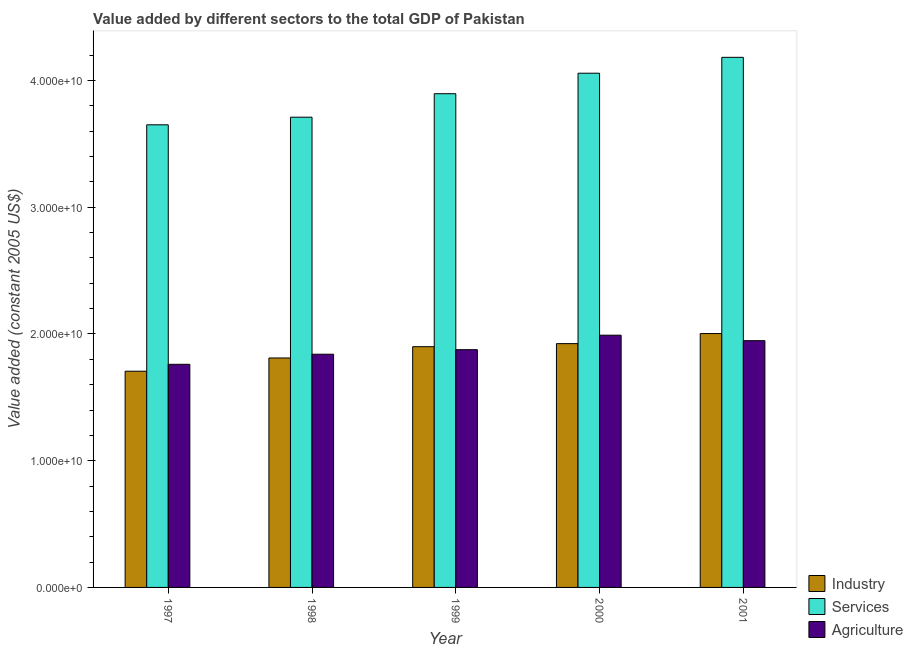How many different coloured bars are there?
Your answer should be compact. 3. How many groups of bars are there?
Your answer should be very brief. 5. Are the number of bars per tick equal to the number of legend labels?
Give a very brief answer. Yes. Are the number of bars on each tick of the X-axis equal?
Offer a terse response. Yes. What is the label of the 1st group of bars from the left?
Your answer should be compact. 1997. What is the value added by services in 2000?
Your answer should be compact. 4.06e+1. Across all years, what is the maximum value added by services?
Offer a very short reply. 4.18e+1. Across all years, what is the minimum value added by services?
Offer a very short reply. 3.65e+1. In which year was the value added by services minimum?
Offer a very short reply. 1997. What is the total value added by services in the graph?
Keep it short and to the point. 1.95e+11. What is the difference between the value added by services in 1997 and that in 2001?
Your answer should be compact. -5.32e+09. What is the difference between the value added by industrial sector in 2001 and the value added by services in 1997?
Your answer should be compact. 2.97e+09. What is the average value added by agricultural sector per year?
Your answer should be very brief. 1.88e+1. In the year 1997, what is the difference between the value added by services and value added by agricultural sector?
Offer a very short reply. 0. What is the ratio of the value added by services in 1998 to that in 2000?
Provide a succinct answer. 0.91. Is the value added by agricultural sector in 1998 less than that in 2001?
Offer a terse response. Yes. Is the difference between the value added by agricultural sector in 1997 and 2000 greater than the difference between the value added by services in 1997 and 2000?
Give a very brief answer. No. What is the difference between the highest and the second highest value added by industrial sector?
Make the answer very short. 7.95e+08. What is the difference between the highest and the lowest value added by agricultural sector?
Offer a very short reply. 2.30e+09. In how many years, is the value added by agricultural sector greater than the average value added by agricultural sector taken over all years?
Your response must be concise. 2. Is the sum of the value added by industrial sector in 1997 and 2000 greater than the maximum value added by agricultural sector across all years?
Ensure brevity in your answer.  Yes. What does the 3rd bar from the left in 1998 represents?
Give a very brief answer. Agriculture. What does the 2nd bar from the right in 1998 represents?
Keep it short and to the point. Services. Is it the case that in every year, the sum of the value added by industrial sector and value added by services is greater than the value added by agricultural sector?
Your response must be concise. Yes. Are all the bars in the graph horizontal?
Ensure brevity in your answer.  No. Does the graph contain any zero values?
Your answer should be compact. No. Does the graph contain grids?
Your answer should be compact. No. Where does the legend appear in the graph?
Make the answer very short. Bottom right. How many legend labels are there?
Give a very brief answer. 3. What is the title of the graph?
Offer a very short reply. Value added by different sectors to the total GDP of Pakistan. Does "Coal sources" appear as one of the legend labels in the graph?
Offer a very short reply. No. What is the label or title of the Y-axis?
Your answer should be compact. Value added (constant 2005 US$). What is the Value added (constant 2005 US$) of Industry in 1997?
Offer a very short reply. 1.71e+1. What is the Value added (constant 2005 US$) of Services in 1997?
Ensure brevity in your answer.  3.65e+1. What is the Value added (constant 2005 US$) of Agriculture in 1997?
Make the answer very short. 1.76e+1. What is the Value added (constant 2005 US$) of Industry in 1998?
Your answer should be compact. 1.81e+1. What is the Value added (constant 2005 US$) of Services in 1998?
Your answer should be compact. 3.71e+1. What is the Value added (constant 2005 US$) in Agriculture in 1998?
Your answer should be compact. 1.84e+1. What is the Value added (constant 2005 US$) of Industry in 1999?
Your response must be concise. 1.90e+1. What is the Value added (constant 2005 US$) in Services in 1999?
Offer a very short reply. 3.90e+1. What is the Value added (constant 2005 US$) in Agriculture in 1999?
Offer a terse response. 1.88e+1. What is the Value added (constant 2005 US$) of Industry in 2000?
Your answer should be very brief. 1.92e+1. What is the Value added (constant 2005 US$) in Services in 2000?
Keep it short and to the point. 4.06e+1. What is the Value added (constant 2005 US$) in Agriculture in 2000?
Your answer should be very brief. 1.99e+1. What is the Value added (constant 2005 US$) in Industry in 2001?
Your answer should be compact. 2.00e+1. What is the Value added (constant 2005 US$) in Services in 2001?
Ensure brevity in your answer.  4.18e+1. What is the Value added (constant 2005 US$) of Agriculture in 2001?
Provide a succinct answer. 1.95e+1. Across all years, what is the maximum Value added (constant 2005 US$) of Industry?
Your answer should be compact. 2.00e+1. Across all years, what is the maximum Value added (constant 2005 US$) of Services?
Provide a short and direct response. 4.18e+1. Across all years, what is the maximum Value added (constant 2005 US$) of Agriculture?
Offer a very short reply. 1.99e+1. Across all years, what is the minimum Value added (constant 2005 US$) of Industry?
Keep it short and to the point. 1.71e+1. Across all years, what is the minimum Value added (constant 2005 US$) of Services?
Your answer should be compact. 3.65e+1. Across all years, what is the minimum Value added (constant 2005 US$) of Agriculture?
Your response must be concise. 1.76e+1. What is the total Value added (constant 2005 US$) in Industry in the graph?
Your answer should be very brief. 9.34e+1. What is the total Value added (constant 2005 US$) of Services in the graph?
Give a very brief answer. 1.95e+11. What is the total Value added (constant 2005 US$) in Agriculture in the graph?
Your answer should be very brief. 9.41e+1. What is the difference between the Value added (constant 2005 US$) of Industry in 1997 and that in 1998?
Make the answer very short. -1.04e+09. What is the difference between the Value added (constant 2005 US$) in Services in 1997 and that in 1998?
Offer a very short reply. -6.00e+08. What is the difference between the Value added (constant 2005 US$) in Agriculture in 1997 and that in 1998?
Offer a very short reply. -7.95e+08. What is the difference between the Value added (constant 2005 US$) of Industry in 1997 and that in 1999?
Give a very brief answer. -1.93e+09. What is the difference between the Value added (constant 2005 US$) of Services in 1997 and that in 1999?
Keep it short and to the point. -2.45e+09. What is the difference between the Value added (constant 2005 US$) in Agriculture in 1997 and that in 1999?
Your response must be concise. -1.15e+09. What is the difference between the Value added (constant 2005 US$) in Industry in 1997 and that in 2000?
Offer a terse response. -2.18e+09. What is the difference between the Value added (constant 2005 US$) of Services in 1997 and that in 2000?
Make the answer very short. -4.07e+09. What is the difference between the Value added (constant 2005 US$) in Agriculture in 1997 and that in 2000?
Your answer should be compact. -2.30e+09. What is the difference between the Value added (constant 2005 US$) in Industry in 1997 and that in 2001?
Make the answer very short. -2.97e+09. What is the difference between the Value added (constant 2005 US$) in Services in 1997 and that in 2001?
Your answer should be very brief. -5.32e+09. What is the difference between the Value added (constant 2005 US$) in Agriculture in 1997 and that in 2001?
Offer a terse response. -1.86e+09. What is the difference between the Value added (constant 2005 US$) of Industry in 1998 and that in 1999?
Make the answer very short. -8.91e+08. What is the difference between the Value added (constant 2005 US$) in Services in 1998 and that in 1999?
Give a very brief answer. -1.85e+09. What is the difference between the Value added (constant 2005 US$) of Agriculture in 1998 and that in 1999?
Give a very brief answer. -3.59e+08. What is the difference between the Value added (constant 2005 US$) in Industry in 1998 and that in 2000?
Your answer should be compact. -1.13e+09. What is the difference between the Value added (constant 2005 US$) of Services in 1998 and that in 2000?
Your answer should be very brief. -3.47e+09. What is the difference between the Value added (constant 2005 US$) in Agriculture in 1998 and that in 2000?
Provide a succinct answer. -1.50e+09. What is the difference between the Value added (constant 2005 US$) of Industry in 1998 and that in 2001?
Make the answer very short. -1.93e+09. What is the difference between the Value added (constant 2005 US$) of Services in 1998 and that in 2001?
Your answer should be very brief. -4.72e+09. What is the difference between the Value added (constant 2005 US$) in Agriculture in 1998 and that in 2001?
Your answer should be compact. -1.07e+09. What is the difference between the Value added (constant 2005 US$) in Industry in 1999 and that in 2000?
Your answer should be compact. -2.42e+08. What is the difference between the Value added (constant 2005 US$) in Services in 1999 and that in 2000?
Keep it short and to the point. -1.62e+09. What is the difference between the Value added (constant 2005 US$) of Agriculture in 1999 and that in 2000?
Keep it short and to the point. -1.14e+09. What is the difference between the Value added (constant 2005 US$) of Industry in 1999 and that in 2001?
Keep it short and to the point. -1.04e+09. What is the difference between the Value added (constant 2005 US$) of Services in 1999 and that in 2001?
Provide a short and direct response. -2.87e+09. What is the difference between the Value added (constant 2005 US$) in Agriculture in 1999 and that in 2001?
Your answer should be compact. -7.10e+08. What is the difference between the Value added (constant 2005 US$) of Industry in 2000 and that in 2001?
Make the answer very short. -7.95e+08. What is the difference between the Value added (constant 2005 US$) of Services in 2000 and that in 2001?
Keep it short and to the point. -1.25e+09. What is the difference between the Value added (constant 2005 US$) of Agriculture in 2000 and that in 2001?
Offer a very short reply. 4.33e+08. What is the difference between the Value added (constant 2005 US$) of Industry in 1997 and the Value added (constant 2005 US$) of Services in 1998?
Provide a succinct answer. -2.00e+1. What is the difference between the Value added (constant 2005 US$) in Industry in 1997 and the Value added (constant 2005 US$) in Agriculture in 1998?
Offer a terse response. -1.34e+09. What is the difference between the Value added (constant 2005 US$) in Services in 1997 and the Value added (constant 2005 US$) in Agriculture in 1998?
Offer a terse response. 1.81e+1. What is the difference between the Value added (constant 2005 US$) of Industry in 1997 and the Value added (constant 2005 US$) of Services in 1999?
Ensure brevity in your answer.  -2.19e+1. What is the difference between the Value added (constant 2005 US$) of Industry in 1997 and the Value added (constant 2005 US$) of Agriculture in 1999?
Your answer should be compact. -1.70e+09. What is the difference between the Value added (constant 2005 US$) of Services in 1997 and the Value added (constant 2005 US$) of Agriculture in 1999?
Provide a succinct answer. 1.77e+1. What is the difference between the Value added (constant 2005 US$) in Industry in 1997 and the Value added (constant 2005 US$) in Services in 2000?
Ensure brevity in your answer.  -2.35e+1. What is the difference between the Value added (constant 2005 US$) of Industry in 1997 and the Value added (constant 2005 US$) of Agriculture in 2000?
Make the answer very short. -2.84e+09. What is the difference between the Value added (constant 2005 US$) of Services in 1997 and the Value added (constant 2005 US$) of Agriculture in 2000?
Give a very brief answer. 1.66e+1. What is the difference between the Value added (constant 2005 US$) of Industry in 1997 and the Value added (constant 2005 US$) of Services in 2001?
Your answer should be very brief. -2.48e+1. What is the difference between the Value added (constant 2005 US$) in Industry in 1997 and the Value added (constant 2005 US$) in Agriculture in 2001?
Make the answer very short. -2.41e+09. What is the difference between the Value added (constant 2005 US$) in Services in 1997 and the Value added (constant 2005 US$) in Agriculture in 2001?
Your answer should be very brief. 1.70e+1. What is the difference between the Value added (constant 2005 US$) in Industry in 1998 and the Value added (constant 2005 US$) in Services in 1999?
Offer a terse response. -2.09e+1. What is the difference between the Value added (constant 2005 US$) in Industry in 1998 and the Value added (constant 2005 US$) in Agriculture in 1999?
Give a very brief answer. -6.55e+08. What is the difference between the Value added (constant 2005 US$) in Services in 1998 and the Value added (constant 2005 US$) in Agriculture in 1999?
Keep it short and to the point. 1.83e+1. What is the difference between the Value added (constant 2005 US$) of Industry in 1998 and the Value added (constant 2005 US$) of Services in 2000?
Your answer should be compact. -2.25e+1. What is the difference between the Value added (constant 2005 US$) of Industry in 1998 and the Value added (constant 2005 US$) of Agriculture in 2000?
Your response must be concise. -1.80e+09. What is the difference between the Value added (constant 2005 US$) of Services in 1998 and the Value added (constant 2005 US$) of Agriculture in 2000?
Your response must be concise. 1.72e+1. What is the difference between the Value added (constant 2005 US$) of Industry in 1998 and the Value added (constant 2005 US$) of Services in 2001?
Offer a terse response. -2.37e+1. What is the difference between the Value added (constant 2005 US$) of Industry in 1998 and the Value added (constant 2005 US$) of Agriculture in 2001?
Make the answer very short. -1.36e+09. What is the difference between the Value added (constant 2005 US$) in Services in 1998 and the Value added (constant 2005 US$) in Agriculture in 2001?
Keep it short and to the point. 1.76e+1. What is the difference between the Value added (constant 2005 US$) in Industry in 1999 and the Value added (constant 2005 US$) in Services in 2000?
Give a very brief answer. -2.16e+1. What is the difference between the Value added (constant 2005 US$) in Industry in 1999 and the Value added (constant 2005 US$) in Agriculture in 2000?
Your answer should be compact. -9.07e+08. What is the difference between the Value added (constant 2005 US$) of Services in 1999 and the Value added (constant 2005 US$) of Agriculture in 2000?
Provide a short and direct response. 1.91e+1. What is the difference between the Value added (constant 2005 US$) in Industry in 1999 and the Value added (constant 2005 US$) in Services in 2001?
Keep it short and to the point. -2.28e+1. What is the difference between the Value added (constant 2005 US$) of Industry in 1999 and the Value added (constant 2005 US$) of Agriculture in 2001?
Offer a terse response. -4.74e+08. What is the difference between the Value added (constant 2005 US$) of Services in 1999 and the Value added (constant 2005 US$) of Agriculture in 2001?
Provide a succinct answer. 1.95e+1. What is the difference between the Value added (constant 2005 US$) of Industry in 2000 and the Value added (constant 2005 US$) of Services in 2001?
Provide a short and direct response. -2.26e+1. What is the difference between the Value added (constant 2005 US$) in Industry in 2000 and the Value added (constant 2005 US$) in Agriculture in 2001?
Give a very brief answer. -2.32e+08. What is the difference between the Value added (constant 2005 US$) in Services in 2000 and the Value added (constant 2005 US$) in Agriculture in 2001?
Provide a succinct answer. 2.11e+1. What is the average Value added (constant 2005 US$) of Industry per year?
Provide a short and direct response. 1.87e+1. What is the average Value added (constant 2005 US$) in Services per year?
Your answer should be compact. 3.90e+1. What is the average Value added (constant 2005 US$) in Agriculture per year?
Your answer should be compact. 1.88e+1. In the year 1997, what is the difference between the Value added (constant 2005 US$) in Industry and Value added (constant 2005 US$) in Services?
Provide a succinct answer. -1.94e+1. In the year 1997, what is the difference between the Value added (constant 2005 US$) in Industry and Value added (constant 2005 US$) in Agriculture?
Provide a short and direct response. -5.44e+08. In the year 1997, what is the difference between the Value added (constant 2005 US$) of Services and Value added (constant 2005 US$) of Agriculture?
Offer a terse response. 1.89e+1. In the year 1998, what is the difference between the Value added (constant 2005 US$) in Industry and Value added (constant 2005 US$) in Services?
Make the answer very short. -1.90e+1. In the year 1998, what is the difference between the Value added (constant 2005 US$) of Industry and Value added (constant 2005 US$) of Agriculture?
Provide a succinct answer. -2.96e+08. In the year 1998, what is the difference between the Value added (constant 2005 US$) of Services and Value added (constant 2005 US$) of Agriculture?
Ensure brevity in your answer.  1.87e+1. In the year 1999, what is the difference between the Value added (constant 2005 US$) of Industry and Value added (constant 2005 US$) of Services?
Make the answer very short. -2.00e+1. In the year 1999, what is the difference between the Value added (constant 2005 US$) in Industry and Value added (constant 2005 US$) in Agriculture?
Your answer should be very brief. 2.36e+08. In the year 1999, what is the difference between the Value added (constant 2005 US$) in Services and Value added (constant 2005 US$) in Agriculture?
Make the answer very short. 2.02e+1. In the year 2000, what is the difference between the Value added (constant 2005 US$) in Industry and Value added (constant 2005 US$) in Services?
Your response must be concise. -2.13e+1. In the year 2000, what is the difference between the Value added (constant 2005 US$) of Industry and Value added (constant 2005 US$) of Agriculture?
Your response must be concise. -6.66e+08. In the year 2000, what is the difference between the Value added (constant 2005 US$) of Services and Value added (constant 2005 US$) of Agriculture?
Give a very brief answer. 2.07e+1. In the year 2001, what is the difference between the Value added (constant 2005 US$) of Industry and Value added (constant 2005 US$) of Services?
Provide a succinct answer. -2.18e+1. In the year 2001, what is the difference between the Value added (constant 2005 US$) in Industry and Value added (constant 2005 US$) in Agriculture?
Ensure brevity in your answer.  5.63e+08. In the year 2001, what is the difference between the Value added (constant 2005 US$) of Services and Value added (constant 2005 US$) of Agriculture?
Offer a very short reply. 2.24e+1. What is the ratio of the Value added (constant 2005 US$) in Industry in 1997 to that in 1998?
Your answer should be compact. 0.94. What is the ratio of the Value added (constant 2005 US$) of Services in 1997 to that in 1998?
Give a very brief answer. 0.98. What is the ratio of the Value added (constant 2005 US$) of Agriculture in 1997 to that in 1998?
Give a very brief answer. 0.96. What is the ratio of the Value added (constant 2005 US$) in Industry in 1997 to that in 1999?
Provide a short and direct response. 0.9. What is the ratio of the Value added (constant 2005 US$) of Services in 1997 to that in 1999?
Give a very brief answer. 0.94. What is the ratio of the Value added (constant 2005 US$) in Agriculture in 1997 to that in 1999?
Offer a terse response. 0.94. What is the ratio of the Value added (constant 2005 US$) in Industry in 1997 to that in 2000?
Make the answer very short. 0.89. What is the ratio of the Value added (constant 2005 US$) of Services in 1997 to that in 2000?
Your response must be concise. 0.9. What is the ratio of the Value added (constant 2005 US$) in Agriculture in 1997 to that in 2000?
Offer a very short reply. 0.88. What is the ratio of the Value added (constant 2005 US$) of Industry in 1997 to that in 2001?
Your answer should be compact. 0.85. What is the ratio of the Value added (constant 2005 US$) of Services in 1997 to that in 2001?
Offer a very short reply. 0.87. What is the ratio of the Value added (constant 2005 US$) in Agriculture in 1997 to that in 2001?
Provide a short and direct response. 0.9. What is the ratio of the Value added (constant 2005 US$) of Industry in 1998 to that in 1999?
Keep it short and to the point. 0.95. What is the ratio of the Value added (constant 2005 US$) in Services in 1998 to that in 1999?
Keep it short and to the point. 0.95. What is the ratio of the Value added (constant 2005 US$) in Agriculture in 1998 to that in 1999?
Make the answer very short. 0.98. What is the ratio of the Value added (constant 2005 US$) in Industry in 1998 to that in 2000?
Offer a very short reply. 0.94. What is the ratio of the Value added (constant 2005 US$) of Services in 1998 to that in 2000?
Provide a succinct answer. 0.91. What is the ratio of the Value added (constant 2005 US$) of Agriculture in 1998 to that in 2000?
Provide a short and direct response. 0.92. What is the ratio of the Value added (constant 2005 US$) in Industry in 1998 to that in 2001?
Offer a terse response. 0.9. What is the ratio of the Value added (constant 2005 US$) of Services in 1998 to that in 2001?
Offer a terse response. 0.89. What is the ratio of the Value added (constant 2005 US$) of Agriculture in 1998 to that in 2001?
Your answer should be compact. 0.95. What is the ratio of the Value added (constant 2005 US$) in Industry in 1999 to that in 2000?
Keep it short and to the point. 0.99. What is the ratio of the Value added (constant 2005 US$) in Services in 1999 to that in 2000?
Keep it short and to the point. 0.96. What is the ratio of the Value added (constant 2005 US$) of Agriculture in 1999 to that in 2000?
Your answer should be compact. 0.94. What is the ratio of the Value added (constant 2005 US$) of Industry in 1999 to that in 2001?
Offer a terse response. 0.95. What is the ratio of the Value added (constant 2005 US$) of Services in 1999 to that in 2001?
Offer a very short reply. 0.93. What is the ratio of the Value added (constant 2005 US$) in Agriculture in 1999 to that in 2001?
Your answer should be compact. 0.96. What is the ratio of the Value added (constant 2005 US$) in Industry in 2000 to that in 2001?
Your answer should be compact. 0.96. What is the ratio of the Value added (constant 2005 US$) in Agriculture in 2000 to that in 2001?
Keep it short and to the point. 1.02. What is the difference between the highest and the second highest Value added (constant 2005 US$) of Industry?
Your answer should be very brief. 7.95e+08. What is the difference between the highest and the second highest Value added (constant 2005 US$) in Services?
Give a very brief answer. 1.25e+09. What is the difference between the highest and the second highest Value added (constant 2005 US$) of Agriculture?
Ensure brevity in your answer.  4.33e+08. What is the difference between the highest and the lowest Value added (constant 2005 US$) of Industry?
Give a very brief answer. 2.97e+09. What is the difference between the highest and the lowest Value added (constant 2005 US$) in Services?
Offer a terse response. 5.32e+09. What is the difference between the highest and the lowest Value added (constant 2005 US$) of Agriculture?
Your answer should be compact. 2.30e+09. 